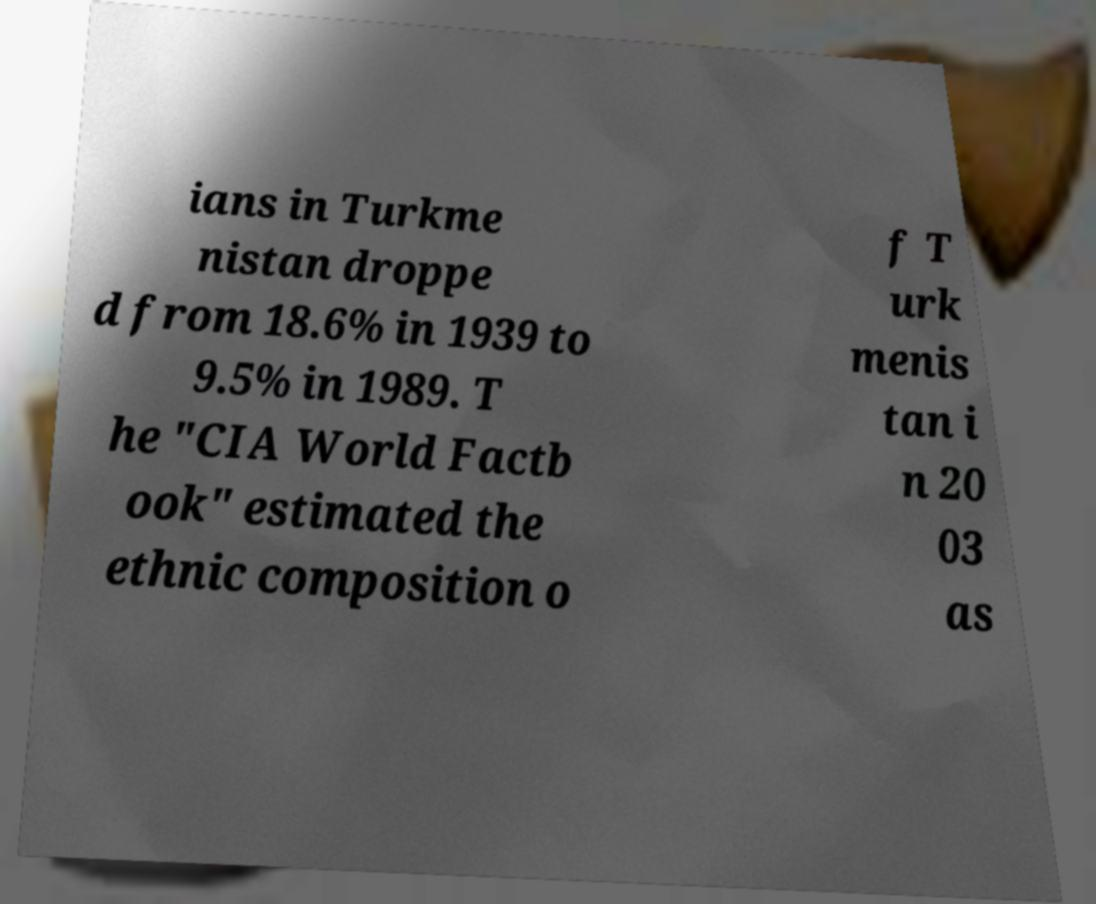Could you extract and type out the text from this image? ians in Turkme nistan droppe d from 18.6% in 1939 to 9.5% in 1989. T he "CIA World Factb ook" estimated the ethnic composition o f T urk menis tan i n 20 03 as 